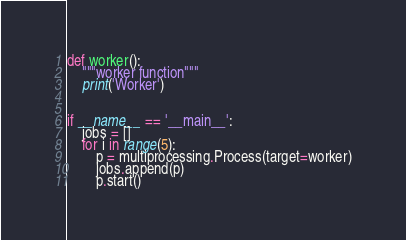Convert code to text. <code><loc_0><loc_0><loc_500><loc_500><_Python_>def worker():
    """worker function"""
    print('Worker')


if __name__ == '__main__':
    jobs = []
    for i in range(5):
        p = multiprocessing.Process(target=worker)
        jobs.append(p)
        p.start()
</code> 